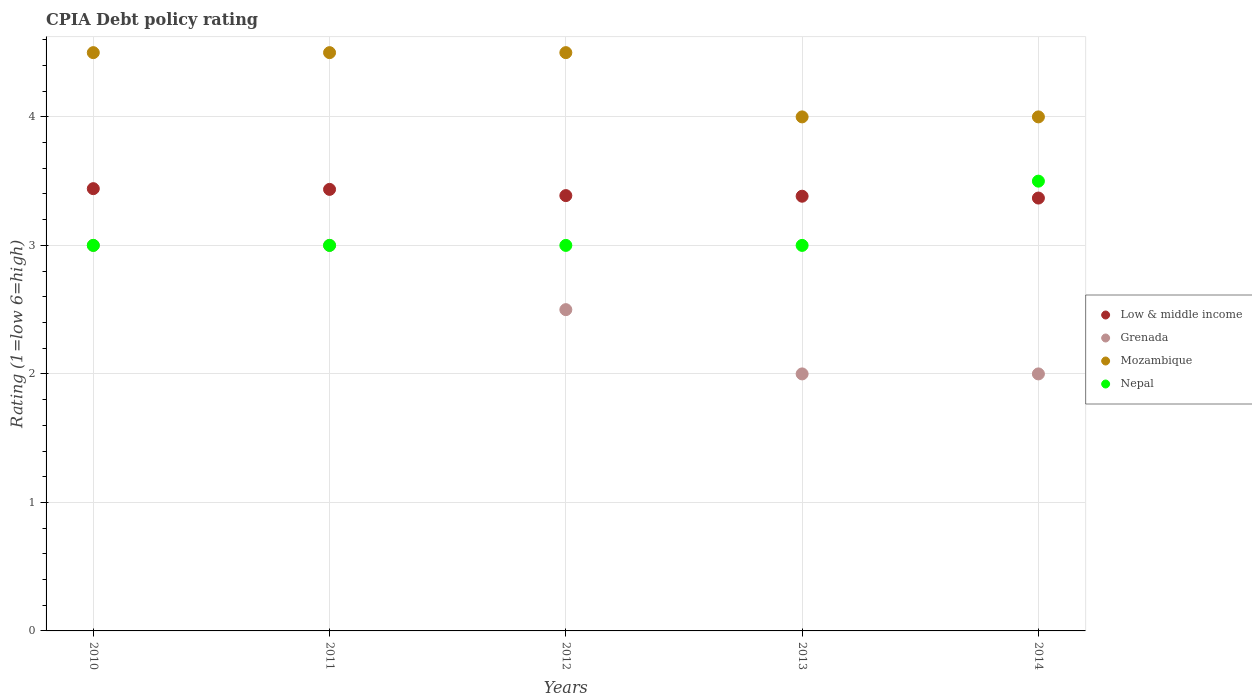Is the number of dotlines equal to the number of legend labels?
Ensure brevity in your answer.  Yes. What is the CPIA rating in Grenada in 2014?
Give a very brief answer. 2. Across all years, what is the maximum CPIA rating in Low & middle income?
Offer a very short reply. 3.44. In which year was the CPIA rating in Mozambique minimum?
Offer a very short reply. 2013. What is the total CPIA rating in Mozambique in the graph?
Offer a terse response. 21.5. What is the difference between the CPIA rating in Nepal in 2013 and the CPIA rating in Low & middle income in 2012?
Give a very brief answer. -0.39. What is the average CPIA rating in Low & middle income per year?
Your answer should be very brief. 3.4. In the year 2014, what is the difference between the CPIA rating in Low & middle income and CPIA rating in Grenada?
Ensure brevity in your answer.  1.37. What is the ratio of the CPIA rating in Low & middle income in 2012 to that in 2013?
Offer a very short reply. 1. Is the difference between the CPIA rating in Low & middle income in 2010 and 2014 greater than the difference between the CPIA rating in Grenada in 2010 and 2014?
Your answer should be very brief. No. What is the difference between the highest and the second highest CPIA rating in Mozambique?
Offer a very short reply. 0. In how many years, is the CPIA rating in Nepal greater than the average CPIA rating in Nepal taken over all years?
Your response must be concise. 1. Is the sum of the CPIA rating in Mozambique in 2011 and 2012 greater than the maximum CPIA rating in Grenada across all years?
Your answer should be compact. Yes. Is it the case that in every year, the sum of the CPIA rating in Mozambique and CPIA rating in Grenada  is greater than the CPIA rating in Low & middle income?
Provide a short and direct response. Yes. Is the CPIA rating in Low & middle income strictly less than the CPIA rating in Grenada over the years?
Your answer should be very brief. No. How many years are there in the graph?
Your answer should be very brief. 5. What is the difference between two consecutive major ticks on the Y-axis?
Your answer should be very brief. 1. Are the values on the major ticks of Y-axis written in scientific E-notation?
Give a very brief answer. No. Does the graph contain any zero values?
Your answer should be very brief. No. Does the graph contain grids?
Give a very brief answer. Yes. What is the title of the graph?
Your response must be concise. CPIA Debt policy rating. Does "Slovak Republic" appear as one of the legend labels in the graph?
Keep it short and to the point. No. What is the Rating (1=low 6=high) in Low & middle income in 2010?
Make the answer very short. 3.44. What is the Rating (1=low 6=high) of Grenada in 2010?
Give a very brief answer. 3. What is the Rating (1=low 6=high) of Mozambique in 2010?
Make the answer very short. 4.5. What is the Rating (1=low 6=high) in Low & middle income in 2011?
Your answer should be compact. 3.44. What is the Rating (1=low 6=high) of Mozambique in 2011?
Offer a very short reply. 4.5. What is the Rating (1=low 6=high) in Nepal in 2011?
Offer a very short reply. 3. What is the Rating (1=low 6=high) in Low & middle income in 2012?
Provide a short and direct response. 3.39. What is the Rating (1=low 6=high) of Mozambique in 2012?
Give a very brief answer. 4.5. What is the Rating (1=low 6=high) of Low & middle income in 2013?
Your answer should be compact. 3.38. What is the Rating (1=low 6=high) of Nepal in 2013?
Keep it short and to the point. 3. What is the Rating (1=low 6=high) of Low & middle income in 2014?
Provide a succinct answer. 3.37. What is the Rating (1=low 6=high) in Grenada in 2014?
Provide a succinct answer. 2. Across all years, what is the maximum Rating (1=low 6=high) of Low & middle income?
Keep it short and to the point. 3.44. Across all years, what is the maximum Rating (1=low 6=high) of Grenada?
Provide a succinct answer. 3. Across all years, what is the maximum Rating (1=low 6=high) in Mozambique?
Give a very brief answer. 4.5. Across all years, what is the minimum Rating (1=low 6=high) in Low & middle income?
Your answer should be very brief. 3.37. Across all years, what is the minimum Rating (1=low 6=high) in Grenada?
Provide a short and direct response. 2. Across all years, what is the minimum Rating (1=low 6=high) of Mozambique?
Give a very brief answer. 4. What is the total Rating (1=low 6=high) in Low & middle income in the graph?
Offer a very short reply. 17.02. What is the difference between the Rating (1=low 6=high) in Low & middle income in 2010 and that in 2011?
Your answer should be compact. 0.01. What is the difference between the Rating (1=low 6=high) in Nepal in 2010 and that in 2011?
Make the answer very short. 0. What is the difference between the Rating (1=low 6=high) of Low & middle income in 2010 and that in 2012?
Your response must be concise. 0.05. What is the difference between the Rating (1=low 6=high) of Grenada in 2010 and that in 2012?
Your answer should be very brief. 0.5. What is the difference between the Rating (1=low 6=high) of Low & middle income in 2010 and that in 2013?
Ensure brevity in your answer.  0.06. What is the difference between the Rating (1=low 6=high) of Nepal in 2010 and that in 2013?
Your response must be concise. 0. What is the difference between the Rating (1=low 6=high) of Low & middle income in 2010 and that in 2014?
Provide a succinct answer. 0.07. What is the difference between the Rating (1=low 6=high) of Nepal in 2010 and that in 2014?
Your answer should be compact. -0.5. What is the difference between the Rating (1=low 6=high) of Low & middle income in 2011 and that in 2012?
Offer a very short reply. 0.05. What is the difference between the Rating (1=low 6=high) in Nepal in 2011 and that in 2012?
Your response must be concise. 0. What is the difference between the Rating (1=low 6=high) of Low & middle income in 2011 and that in 2013?
Make the answer very short. 0.05. What is the difference between the Rating (1=low 6=high) of Grenada in 2011 and that in 2013?
Give a very brief answer. 1. What is the difference between the Rating (1=low 6=high) in Mozambique in 2011 and that in 2013?
Make the answer very short. 0.5. What is the difference between the Rating (1=low 6=high) in Low & middle income in 2011 and that in 2014?
Give a very brief answer. 0.07. What is the difference between the Rating (1=low 6=high) of Grenada in 2011 and that in 2014?
Provide a short and direct response. 1. What is the difference between the Rating (1=low 6=high) in Low & middle income in 2012 and that in 2013?
Give a very brief answer. 0. What is the difference between the Rating (1=low 6=high) in Nepal in 2012 and that in 2013?
Offer a terse response. 0. What is the difference between the Rating (1=low 6=high) of Low & middle income in 2012 and that in 2014?
Offer a terse response. 0.02. What is the difference between the Rating (1=low 6=high) in Grenada in 2012 and that in 2014?
Provide a short and direct response. 0.5. What is the difference between the Rating (1=low 6=high) of Low & middle income in 2013 and that in 2014?
Offer a very short reply. 0.01. What is the difference between the Rating (1=low 6=high) in Mozambique in 2013 and that in 2014?
Your response must be concise. 0. What is the difference between the Rating (1=low 6=high) in Low & middle income in 2010 and the Rating (1=low 6=high) in Grenada in 2011?
Offer a terse response. 0.44. What is the difference between the Rating (1=low 6=high) of Low & middle income in 2010 and the Rating (1=low 6=high) of Mozambique in 2011?
Offer a terse response. -1.06. What is the difference between the Rating (1=low 6=high) in Low & middle income in 2010 and the Rating (1=low 6=high) in Nepal in 2011?
Give a very brief answer. 0.44. What is the difference between the Rating (1=low 6=high) in Grenada in 2010 and the Rating (1=low 6=high) in Mozambique in 2011?
Make the answer very short. -1.5. What is the difference between the Rating (1=low 6=high) in Low & middle income in 2010 and the Rating (1=low 6=high) in Grenada in 2012?
Make the answer very short. 0.94. What is the difference between the Rating (1=low 6=high) of Low & middle income in 2010 and the Rating (1=low 6=high) of Mozambique in 2012?
Ensure brevity in your answer.  -1.06. What is the difference between the Rating (1=low 6=high) in Low & middle income in 2010 and the Rating (1=low 6=high) in Nepal in 2012?
Offer a very short reply. 0.44. What is the difference between the Rating (1=low 6=high) of Mozambique in 2010 and the Rating (1=low 6=high) of Nepal in 2012?
Your response must be concise. 1.5. What is the difference between the Rating (1=low 6=high) in Low & middle income in 2010 and the Rating (1=low 6=high) in Grenada in 2013?
Provide a short and direct response. 1.44. What is the difference between the Rating (1=low 6=high) in Low & middle income in 2010 and the Rating (1=low 6=high) in Mozambique in 2013?
Your answer should be very brief. -0.56. What is the difference between the Rating (1=low 6=high) of Low & middle income in 2010 and the Rating (1=low 6=high) of Nepal in 2013?
Offer a very short reply. 0.44. What is the difference between the Rating (1=low 6=high) of Grenada in 2010 and the Rating (1=low 6=high) of Mozambique in 2013?
Provide a succinct answer. -1. What is the difference between the Rating (1=low 6=high) of Low & middle income in 2010 and the Rating (1=low 6=high) of Grenada in 2014?
Your answer should be compact. 1.44. What is the difference between the Rating (1=low 6=high) in Low & middle income in 2010 and the Rating (1=low 6=high) in Mozambique in 2014?
Offer a terse response. -0.56. What is the difference between the Rating (1=low 6=high) of Low & middle income in 2010 and the Rating (1=low 6=high) of Nepal in 2014?
Provide a succinct answer. -0.06. What is the difference between the Rating (1=low 6=high) of Grenada in 2010 and the Rating (1=low 6=high) of Mozambique in 2014?
Provide a short and direct response. -1. What is the difference between the Rating (1=low 6=high) in Grenada in 2010 and the Rating (1=low 6=high) in Nepal in 2014?
Offer a terse response. -0.5. What is the difference between the Rating (1=low 6=high) of Low & middle income in 2011 and the Rating (1=low 6=high) of Grenada in 2012?
Make the answer very short. 0.94. What is the difference between the Rating (1=low 6=high) of Low & middle income in 2011 and the Rating (1=low 6=high) of Mozambique in 2012?
Your response must be concise. -1.06. What is the difference between the Rating (1=low 6=high) of Low & middle income in 2011 and the Rating (1=low 6=high) of Nepal in 2012?
Your response must be concise. 0.44. What is the difference between the Rating (1=low 6=high) in Low & middle income in 2011 and the Rating (1=low 6=high) in Grenada in 2013?
Your answer should be very brief. 1.44. What is the difference between the Rating (1=low 6=high) of Low & middle income in 2011 and the Rating (1=low 6=high) of Mozambique in 2013?
Provide a succinct answer. -0.56. What is the difference between the Rating (1=low 6=high) in Low & middle income in 2011 and the Rating (1=low 6=high) in Nepal in 2013?
Offer a very short reply. 0.44. What is the difference between the Rating (1=low 6=high) in Grenada in 2011 and the Rating (1=low 6=high) in Mozambique in 2013?
Give a very brief answer. -1. What is the difference between the Rating (1=low 6=high) in Low & middle income in 2011 and the Rating (1=low 6=high) in Grenada in 2014?
Provide a succinct answer. 1.44. What is the difference between the Rating (1=low 6=high) of Low & middle income in 2011 and the Rating (1=low 6=high) of Mozambique in 2014?
Give a very brief answer. -0.56. What is the difference between the Rating (1=low 6=high) in Low & middle income in 2011 and the Rating (1=low 6=high) in Nepal in 2014?
Your response must be concise. -0.06. What is the difference between the Rating (1=low 6=high) in Grenada in 2011 and the Rating (1=low 6=high) in Nepal in 2014?
Make the answer very short. -0.5. What is the difference between the Rating (1=low 6=high) in Low & middle income in 2012 and the Rating (1=low 6=high) in Grenada in 2013?
Your response must be concise. 1.39. What is the difference between the Rating (1=low 6=high) of Low & middle income in 2012 and the Rating (1=low 6=high) of Mozambique in 2013?
Provide a succinct answer. -0.61. What is the difference between the Rating (1=low 6=high) in Low & middle income in 2012 and the Rating (1=low 6=high) in Nepal in 2013?
Offer a terse response. 0.39. What is the difference between the Rating (1=low 6=high) in Grenada in 2012 and the Rating (1=low 6=high) in Mozambique in 2013?
Give a very brief answer. -1.5. What is the difference between the Rating (1=low 6=high) of Mozambique in 2012 and the Rating (1=low 6=high) of Nepal in 2013?
Keep it short and to the point. 1.5. What is the difference between the Rating (1=low 6=high) in Low & middle income in 2012 and the Rating (1=low 6=high) in Grenada in 2014?
Your answer should be very brief. 1.39. What is the difference between the Rating (1=low 6=high) in Low & middle income in 2012 and the Rating (1=low 6=high) in Mozambique in 2014?
Keep it short and to the point. -0.61. What is the difference between the Rating (1=low 6=high) in Low & middle income in 2012 and the Rating (1=low 6=high) in Nepal in 2014?
Give a very brief answer. -0.11. What is the difference between the Rating (1=low 6=high) in Low & middle income in 2013 and the Rating (1=low 6=high) in Grenada in 2014?
Your answer should be very brief. 1.38. What is the difference between the Rating (1=low 6=high) in Low & middle income in 2013 and the Rating (1=low 6=high) in Mozambique in 2014?
Your answer should be very brief. -0.62. What is the difference between the Rating (1=low 6=high) of Low & middle income in 2013 and the Rating (1=low 6=high) of Nepal in 2014?
Offer a very short reply. -0.12. What is the difference between the Rating (1=low 6=high) of Grenada in 2013 and the Rating (1=low 6=high) of Nepal in 2014?
Your answer should be compact. -1.5. What is the difference between the Rating (1=low 6=high) of Mozambique in 2013 and the Rating (1=low 6=high) of Nepal in 2014?
Keep it short and to the point. 0.5. What is the average Rating (1=low 6=high) of Low & middle income per year?
Keep it short and to the point. 3.4. What is the average Rating (1=low 6=high) of Grenada per year?
Provide a succinct answer. 2.5. What is the average Rating (1=low 6=high) of Nepal per year?
Offer a very short reply. 3.1. In the year 2010, what is the difference between the Rating (1=low 6=high) in Low & middle income and Rating (1=low 6=high) in Grenada?
Provide a succinct answer. 0.44. In the year 2010, what is the difference between the Rating (1=low 6=high) of Low & middle income and Rating (1=low 6=high) of Mozambique?
Your answer should be compact. -1.06. In the year 2010, what is the difference between the Rating (1=low 6=high) of Low & middle income and Rating (1=low 6=high) of Nepal?
Your response must be concise. 0.44. In the year 2010, what is the difference between the Rating (1=low 6=high) of Grenada and Rating (1=low 6=high) of Mozambique?
Keep it short and to the point. -1.5. In the year 2011, what is the difference between the Rating (1=low 6=high) in Low & middle income and Rating (1=low 6=high) in Grenada?
Give a very brief answer. 0.44. In the year 2011, what is the difference between the Rating (1=low 6=high) of Low & middle income and Rating (1=low 6=high) of Mozambique?
Keep it short and to the point. -1.06. In the year 2011, what is the difference between the Rating (1=low 6=high) of Low & middle income and Rating (1=low 6=high) of Nepal?
Keep it short and to the point. 0.44. In the year 2011, what is the difference between the Rating (1=low 6=high) in Grenada and Rating (1=low 6=high) in Mozambique?
Ensure brevity in your answer.  -1.5. In the year 2011, what is the difference between the Rating (1=low 6=high) in Grenada and Rating (1=low 6=high) in Nepal?
Provide a short and direct response. 0. In the year 2012, what is the difference between the Rating (1=low 6=high) of Low & middle income and Rating (1=low 6=high) of Grenada?
Give a very brief answer. 0.89. In the year 2012, what is the difference between the Rating (1=low 6=high) of Low & middle income and Rating (1=low 6=high) of Mozambique?
Offer a very short reply. -1.11. In the year 2012, what is the difference between the Rating (1=low 6=high) in Low & middle income and Rating (1=low 6=high) in Nepal?
Your answer should be very brief. 0.39. In the year 2012, what is the difference between the Rating (1=low 6=high) of Grenada and Rating (1=low 6=high) of Mozambique?
Your answer should be compact. -2. In the year 2013, what is the difference between the Rating (1=low 6=high) of Low & middle income and Rating (1=low 6=high) of Grenada?
Your answer should be very brief. 1.38. In the year 2013, what is the difference between the Rating (1=low 6=high) in Low & middle income and Rating (1=low 6=high) in Mozambique?
Ensure brevity in your answer.  -0.62. In the year 2013, what is the difference between the Rating (1=low 6=high) in Low & middle income and Rating (1=low 6=high) in Nepal?
Your answer should be very brief. 0.38. In the year 2014, what is the difference between the Rating (1=low 6=high) of Low & middle income and Rating (1=low 6=high) of Grenada?
Make the answer very short. 1.37. In the year 2014, what is the difference between the Rating (1=low 6=high) in Low & middle income and Rating (1=low 6=high) in Mozambique?
Give a very brief answer. -0.63. In the year 2014, what is the difference between the Rating (1=low 6=high) of Low & middle income and Rating (1=low 6=high) of Nepal?
Your answer should be very brief. -0.13. In the year 2014, what is the difference between the Rating (1=low 6=high) in Grenada and Rating (1=low 6=high) in Mozambique?
Offer a very short reply. -2. In the year 2014, what is the difference between the Rating (1=low 6=high) in Mozambique and Rating (1=low 6=high) in Nepal?
Ensure brevity in your answer.  0.5. What is the ratio of the Rating (1=low 6=high) in Low & middle income in 2010 to that in 2011?
Provide a short and direct response. 1. What is the ratio of the Rating (1=low 6=high) of Grenada in 2010 to that in 2011?
Your answer should be very brief. 1. What is the ratio of the Rating (1=low 6=high) of Grenada in 2010 to that in 2012?
Keep it short and to the point. 1.2. What is the ratio of the Rating (1=low 6=high) of Nepal in 2010 to that in 2012?
Ensure brevity in your answer.  1. What is the ratio of the Rating (1=low 6=high) in Low & middle income in 2010 to that in 2013?
Keep it short and to the point. 1.02. What is the ratio of the Rating (1=low 6=high) of Grenada in 2010 to that in 2013?
Your response must be concise. 1.5. What is the ratio of the Rating (1=low 6=high) of Low & middle income in 2010 to that in 2014?
Give a very brief answer. 1.02. What is the ratio of the Rating (1=low 6=high) of Low & middle income in 2011 to that in 2012?
Your answer should be very brief. 1.01. What is the ratio of the Rating (1=low 6=high) in Grenada in 2011 to that in 2012?
Make the answer very short. 1.2. What is the ratio of the Rating (1=low 6=high) of Nepal in 2011 to that in 2012?
Make the answer very short. 1. What is the ratio of the Rating (1=low 6=high) in Low & middle income in 2011 to that in 2013?
Offer a terse response. 1.02. What is the ratio of the Rating (1=low 6=high) in Grenada in 2011 to that in 2013?
Provide a short and direct response. 1.5. What is the ratio of the Rating (1=low 6=high) of Nepal in 2011 to that in 2013?
Your response must be concise. 1. What is the ratio of the Rating (1=low 6=high) in Nepal in 2011 to that in 2014?
Offer a terse response. 0.86. What is the ratio of the Rating (1=low 6=high) of Low & middle income in 2012 to that in 2013?
Keep it short and to the point. 1. What is the ratio of the Rating (1=low 6=high) in Grenada in 2012 to that in 2013?
Make the answer very short. 1.25. What is the ratio of the Rating (1=low 6=high) of Mozambique in 2012 to that in 2013?
Your answer should be compact. 1.12. What is the ratio of the Rating (1=low 6=high) of Nepal in 2012 to that in 2013?
Your answer should be compact. 1. What is the ratio of the Rating (1=low 6=high) of Nepal in 2012 to that in 2014?
Provide a succinct answer. 0.86. What is the ratio of the Rating (1=low 6=high) of Low & middle income in 2013 to that in 2014?
Your response must be concise. 1. What is the ratio of the Rating (1=low 6=high) of Grenada in 2013 to that in 2014?
Keep it short and to the point. 1. What is the ratio of the Rating (1=low 6=high) in Mozambique in 2013 to that in 2014?
Your answer should be very brief. 1. What is the difference between the highest and the second highest Rating (1=low 6=high) in Low & middle income?
Give a very brief answer. 0.01. What is the difference between the highest and the second highest Rating (1=low 6=high) of Nepal?
Keep it short and to the point. 0.5. What is the difference between the highest and the lowest Rating (1=low 6=high) in Low & middle income?
Ensure brevity in your answer.  0.07. What is the difference between the highest and the lowest Rating (1=low 6=high) of Grenada?
Offer a very short reply. 1. 